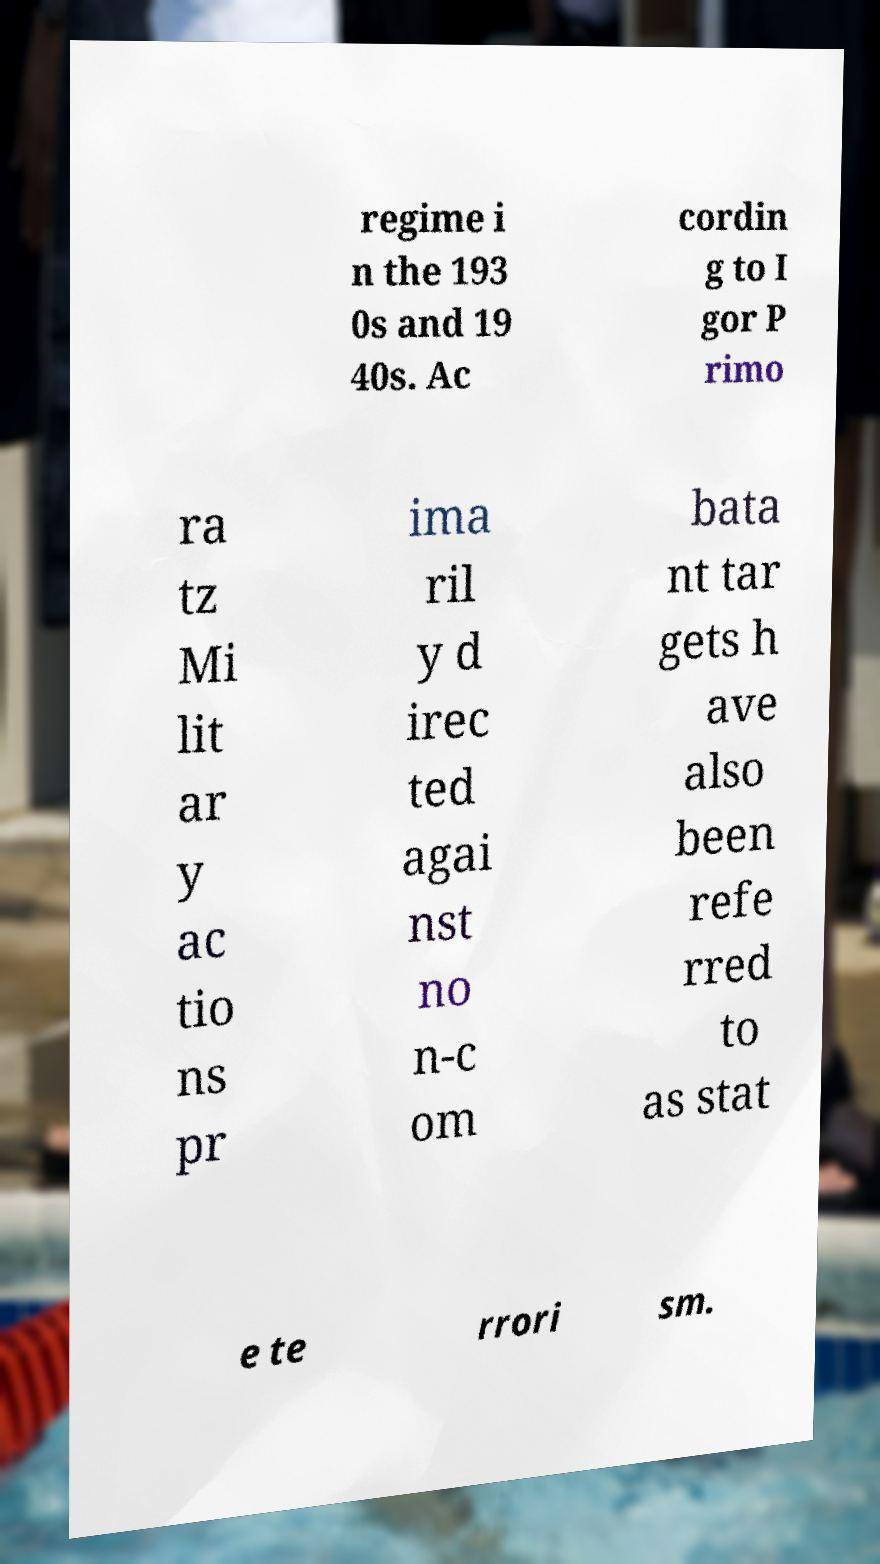Could you extract and type out the text from this image? regime i n the 193 0s and 19 40s. Ac cordin g to I gor P rimo ra tz Mi lit ar y ac tio ns pr ima ril y d irec ted agai nst no n-c om bata nt tar gets h ave also been refe rred to as stat e te rrori sm. 